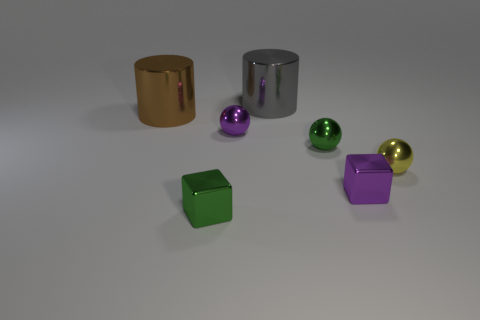Subtract all yellow metallic balls. How many balls are left? 2 Add 3 cylinders. How many objects exist? 10 Subtract all brown cylinders. How many cylinders are left? 1 Subtract all small purple metal things. Subtract all yellow shiny spheres. How many objects are left? 4 Add 2 tiny yellow metallic objects. How many tiny yellow metallic objects are left? 3 Add 3 tiny red metal balls. How many tiny red metal balls exist? 3 Subtract 1 gray cylinders. How many objects are left? 6 Subtract all balls. How many objects are left? 4 Subtract 2 cylinders. How many cylinders are left? 0 Subtract all green blocks. Subtract all cyan cylinders. How many blocks are left? 1 